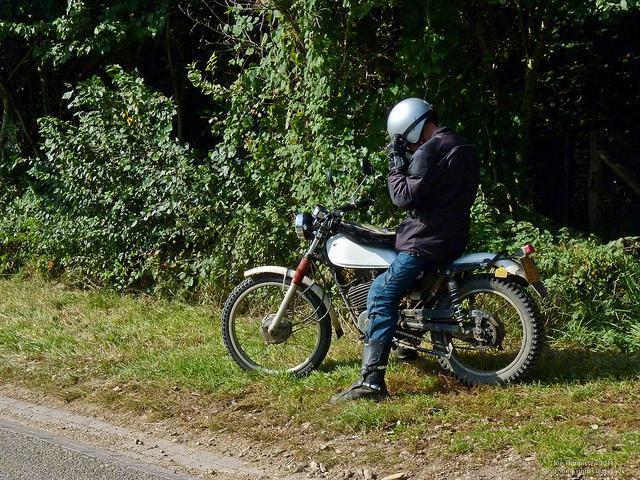How many riders do you see?
Give a very brief answer. 1. 